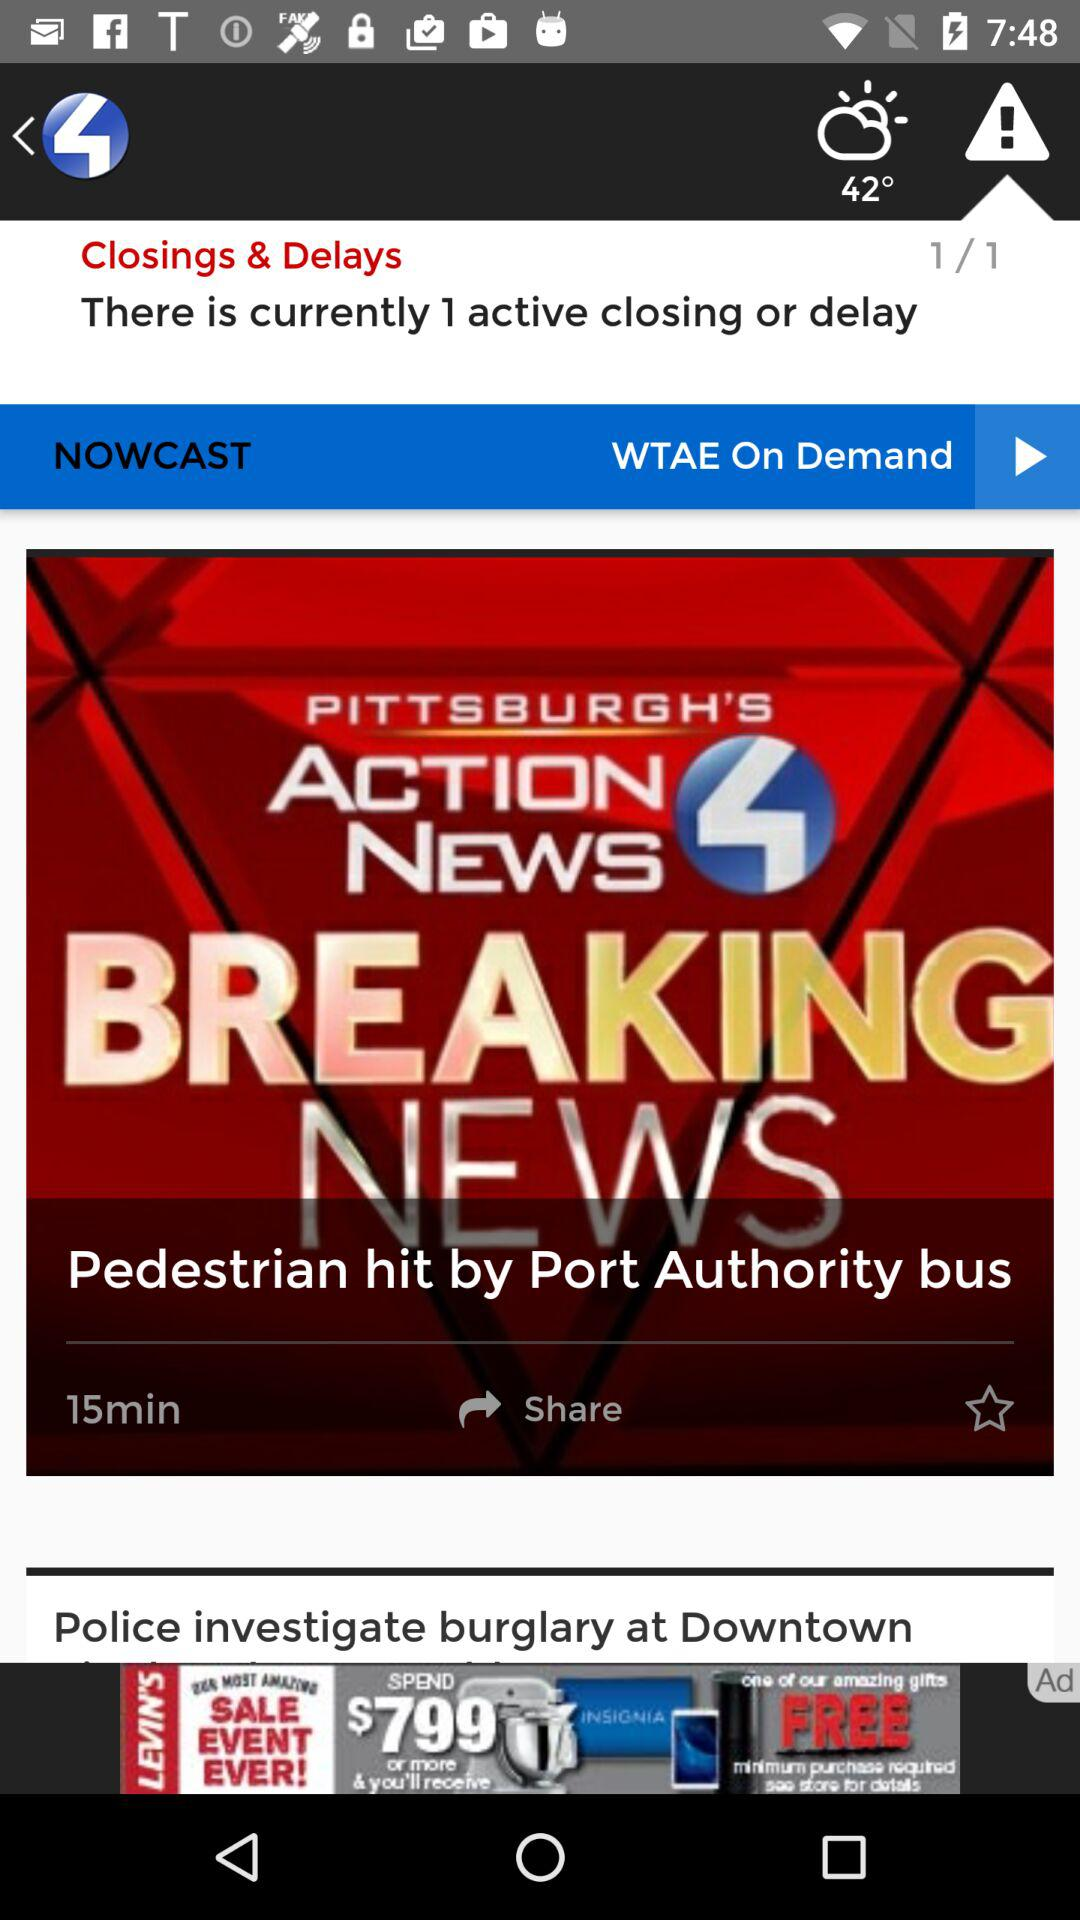How many closings and delays are active? There is 1 active closing and delay. 